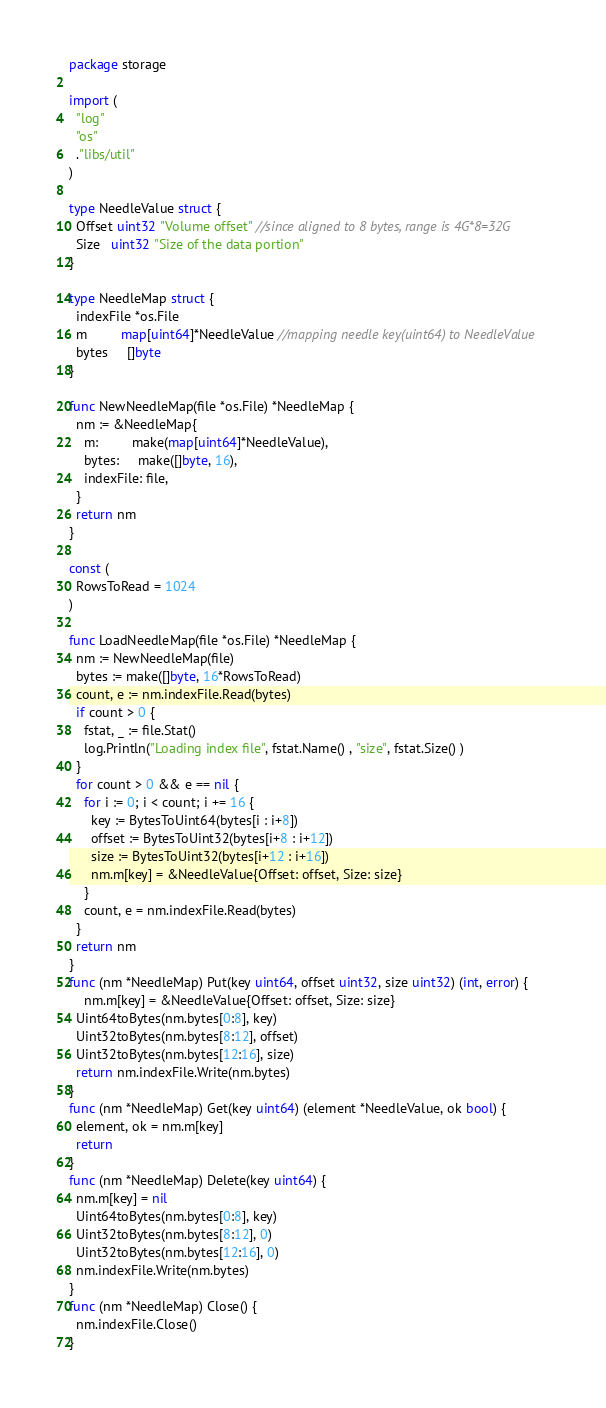Convert code to text. <code><loc_0><loc_0><loc_500><loc_500><_Go_>package storage

import (
  "log"
  "os"
  ."libs/util"
)

type NeedleValue struct {
  Offset uint32 "Volume offset" //since aligned to 8 bytes, range is 4G*8=32G
  Size   uint32 "Size of the data portion"
}

type NeedleMap struct {
  indexFile *os.File
  m         map[uint64]*NeedleValue //mapping needle key(uint64) to NeedleValue
  bytes     []byte
}

func NewNeedleMap(file *os.File) *NeedleMap {
  nm := &NeedleMap{
    m:         make(map[uint64]*NeedleValue),
    bytes:     make([]byte, 16),
    indexFile: file,
  }
  return nm
}

const (
  RowsToRead = 1024
)

func LoadNeedleMap(file *os.File) *NeedleMap {
  nm := NewNeedleMap(file)
  bytes := make([]byte, 16*RowsToRead)
  count, e := nm.indexFile.Read(bytes)
  if count > 0 {
    fstat, _ := file.Stat()
    log.Println("Loading index file", fstat.Name() , "size", fstat.Size() )
  }
  for count > 0 && e == nil {
    for i := 0; i < count; i += 16 {
      key := BytesToUint64(bytes[i : i+8])
      offset := BytesToUint32(bytes[i+8 : i+12])
      size := BytesToUint32(bytes[i+12 : i+16])
      nm.m[key] = &NeedleValue{Offset: offset, Size: size}
    }
    count, e = nm.indexFile.Read(bytes)
  }
  return nm
}
func (nm *NeedleMap) Put(key uint64, offset uint32, size uint32) (int, error) {
    nm.m[key] = &NeedleValue{Offset: offset, Size: size}
  Uint64toBytes(nm.bytes[0:8], key)
  Uint32toBytes(nm.bytes[8:12], offset)
  Uint32toBytes(nm.bytes[12:16], size)
  return nm.indexFile.Write(nm.bytes)
}
func (nm *NeedleMap) Get(key uint64) (element *NeedleValue, ok bool) {
  element, ok = nm.m[key]
  return
}
func (nm *NeedleMap) Delete(key uint64) {
  nm.m[key] = nil
  Uint64toBytes(nm.bytes[0:8], key)
  Uint32toBytes(nm.bytes[8:12], 0)
  Uint32toBytes(nm.bytes[12:16], 0)
  nm.indexFile.Write(nm.bytes)
}
func (nm *NeedleMap) Close() {
  nm.indexFile.Close()
}
</code> 